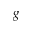<formula> <loc_0><loc_0><loc_500><loc_500>g</formula> 